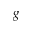<formula> <loc_0><loc_0><loc_500><loc_500>g</formula> 